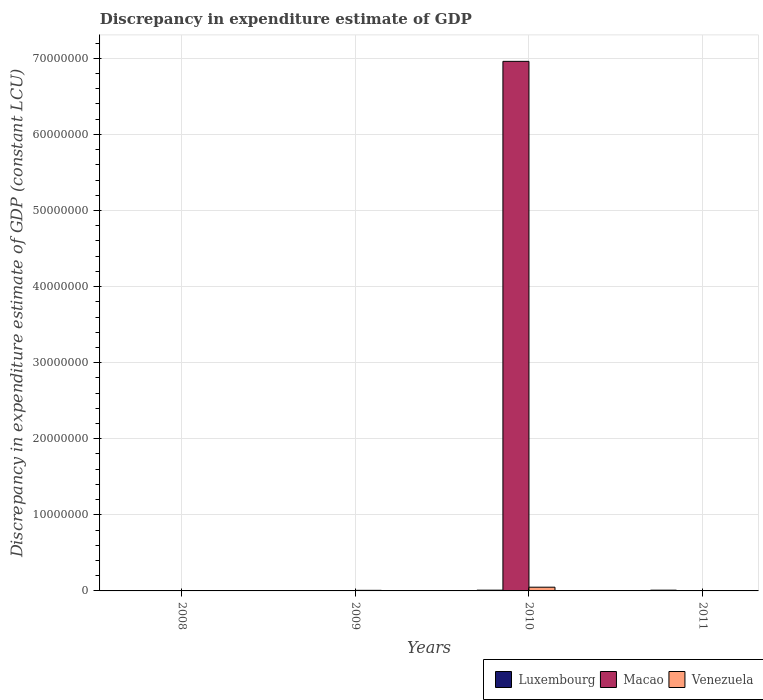How many different coloured bars are there?
Your response must be concise. 3. Are the number of bars on each tick of the X-axis equal?
Offer a very short reply. No. What is the label of the 1st group of bars from the left?
Give a very brief answer. 2008. In how many cases, is the number of bars for a given year not equal to the number of legend labels?
Your answer should be very brief. 3. Across all years, what is the minimum discrepancy in expenditure estimate of GDP in Venezuela?
Your answer should be very brief. 0. In which year was the discrepancy in expenditure estimate of GDP in Luxembourg maximum?
Offer a very short reply. 2010. What is the total discrepancy in expenditure estimate of GDP in Macao in the graph?
Ensure brevity in your answer.  6.96e+07. What is the difference between the discrepancy in expenditure estimate of GDP in Venezuela in 2011 and the discrepancy in expenditure estimate of GDP in Luxembourg in 2010?
Give a very brief answer. -1.00e+05. What is the average discrepancy in expenditure estimate of GDP in Macao per year?
Your response must be concise. 1.74e+07. In the year 2010, what is the difference between the discrepancy in expenditure estimate of GDP in Luxembourg and discrepancy in expenditure estimate of GDP in Macao?
Your answer should be compact. -6.95e+07. What is the difference between the highest and the lowest discrepancy in expenditure estimate of GDP in Macao?
Offer a terse response. 6.96e+07. Is it the case that in every year, the sum of the discrepancy in expenditure estimate of GDP in Venezuela and discrepancy in expenditure estimate of GDP in Macao is greater than the discrepancy in expenditure estimate of GDP in Luxembourg?
Make the answer very short. No. Are all the bars in the graph horizontal?
Ensure brevity in your answer.  No. What is the difference between two consecutive major ticks on the Y-axis?
Give a very brief answer. 1.00e+07. Does the graph contain grids?
Provide a short and direct response. Yes. What is the title of the graph?
Keep it short and to the point. Discrepancy in expenditure estimate of GDP. Does "New Zealand" appear as one of the legend labels in the graph?
Offer a terse response. No. What is the label or title of the Y-axis?
Your answer should be compact. Discrepancy in expenditure estimate of GDP (constant LCU). What is the Discrepancy in expenditure estimate of GDP (constant LCU) of Macao in 2008?
Give a very brief answer. 0. What is the Discrepancy in expenditure estimate of GDP (constant LCU) in Macao in 2009?
Offer a terse response. 0. What is the Discrepancy in expenditure estimate of GDP (constant LCU) of Venezuela in 2009?
Ensure brevity in your answer.  7.60e+04. What is the Discrepancy in expenditure estimate of GDP (constant LCU) in Macao in 2010?
Your answer should be very brief. 6.96e+07. What is the Discrepancy in expenditure estimate of GDP (constant LCU) in Luxembourg in 2011?
Keep it short and to the point. 1.00e+05. What is the Discrepancy in expenditure estimate of GDP (constant LCU) of Macao in 2011?
Your response must be concise. 0. Across all years, what is the maximum Discrepancy in expenditure estimate of GDP (constant LCU) of Luxembourg?
Your answer should be compact. 1.00e+05. Across all years, what is the maximum Discrepancy in expenditure estimate of GDP (constant LCU) of Macao?
Ensure brevity in your answer.  6.96e+07. Across all years, what is the minimum Discrepancy in expenditure estimate of GDP (constant LCU) in Luxembourg?
Give a very brief answer. 0. Across all years, what is the minimum Discrepancy in expenditure estimate of GDP (constant LCU) in Macao?
Your response must be concise. 0. Across all years, what is the minimum Discrepancy in expenditure estimate of GDP (constant LCU) of Venezuela?
Provide a succinct answer. 0. What is the total Discrepancy in expenditure estimate of GDP (constant LCU) in Luxembourg in the graph?
Make the answer very short. 2.00e+05. What is the total Discrepancy in expenditure estimate of GDP (constant LCU) of Macao in the graph?
Ensure brevity in your answer.  6.96e+07. What is the total Discrepancy in expenditure estimate of GDP (constant LCU) in Venezuela in the graph?
Provide a succinct answer. 5.66e+05. What is the difference between the Discrepancy in expenditure estimate of GDP (constant LCU) in Venezuela in 2009 and that in 2010?
Ensure brevity in your answer.  -4.14e+05. What is the difference between the Discrepancy in expenditure estimate of GDP (constant LCU) in Luxembourg in 2010 and that in 2011?
Your answer should be very brief. 0. What is the average Discrepancy in expenditure estimate of GDP (constant LCU) in Luxembourg per year?
Ensure brevity in your answer.  5.00e+04. What is the average Discrepancy in expenditure estimate of GDP (constant LCU) in Macao per year?
Your answer should be compact. 1.74e+07. What is the average Discrepancy in expenditure estimate of GDP (constant LCU) in Venezuela per year?
Make the answer very short. 1.42e+05. In the year 2010, what is the difference between the Discrepancy in expenditure estimate of GDP (constant LCU) of Luxembourg and Discrepancy in expenditure estimate of GDP (constant LCU) of Macao?
Offer a terse response. -6.95e+07. In the year 2010, what is the difference between the Discrepancy in expenditure estimate of GDP (constant LCU) in Luxembourg and Discrepancy in expenditure estimate of GDP (constant LCU) in Venezuela?
Your answer should be compact. -3.90e+05. In the year 2010, what is the difference between the Discrepancy in expenditure estimate of GDP (constant LCU) in Macao and Discrepancy in expenditure estimate of GDP (constant LCU) in Venezuela?
Your answer should be very brief. 6.91e+07. What is the ratio of the Discrepancy in expenditure estimate of GDP (constant LCU) of Venezuela in 2009 to that in 2010?
Ensure brevity in your answer.  0.16. What is the ratio of the Discrepancy in expenditure estimate of GDP (constant LCU) in Luxembourg in 2010 to that in 2011?
Your answer should be compact. 1. What is the difference between the highest and the lowest Discrepancy in expenditure estimate of GDP (constant LCU) of Luxembourg?
Give a very brief answer. 1.00e+05. What is the difference between the highest and the lowest Discrepancy in expenditure estimate of GDP (constant LCU) in Macao?
Make the answer very short. 6.96e+07. 